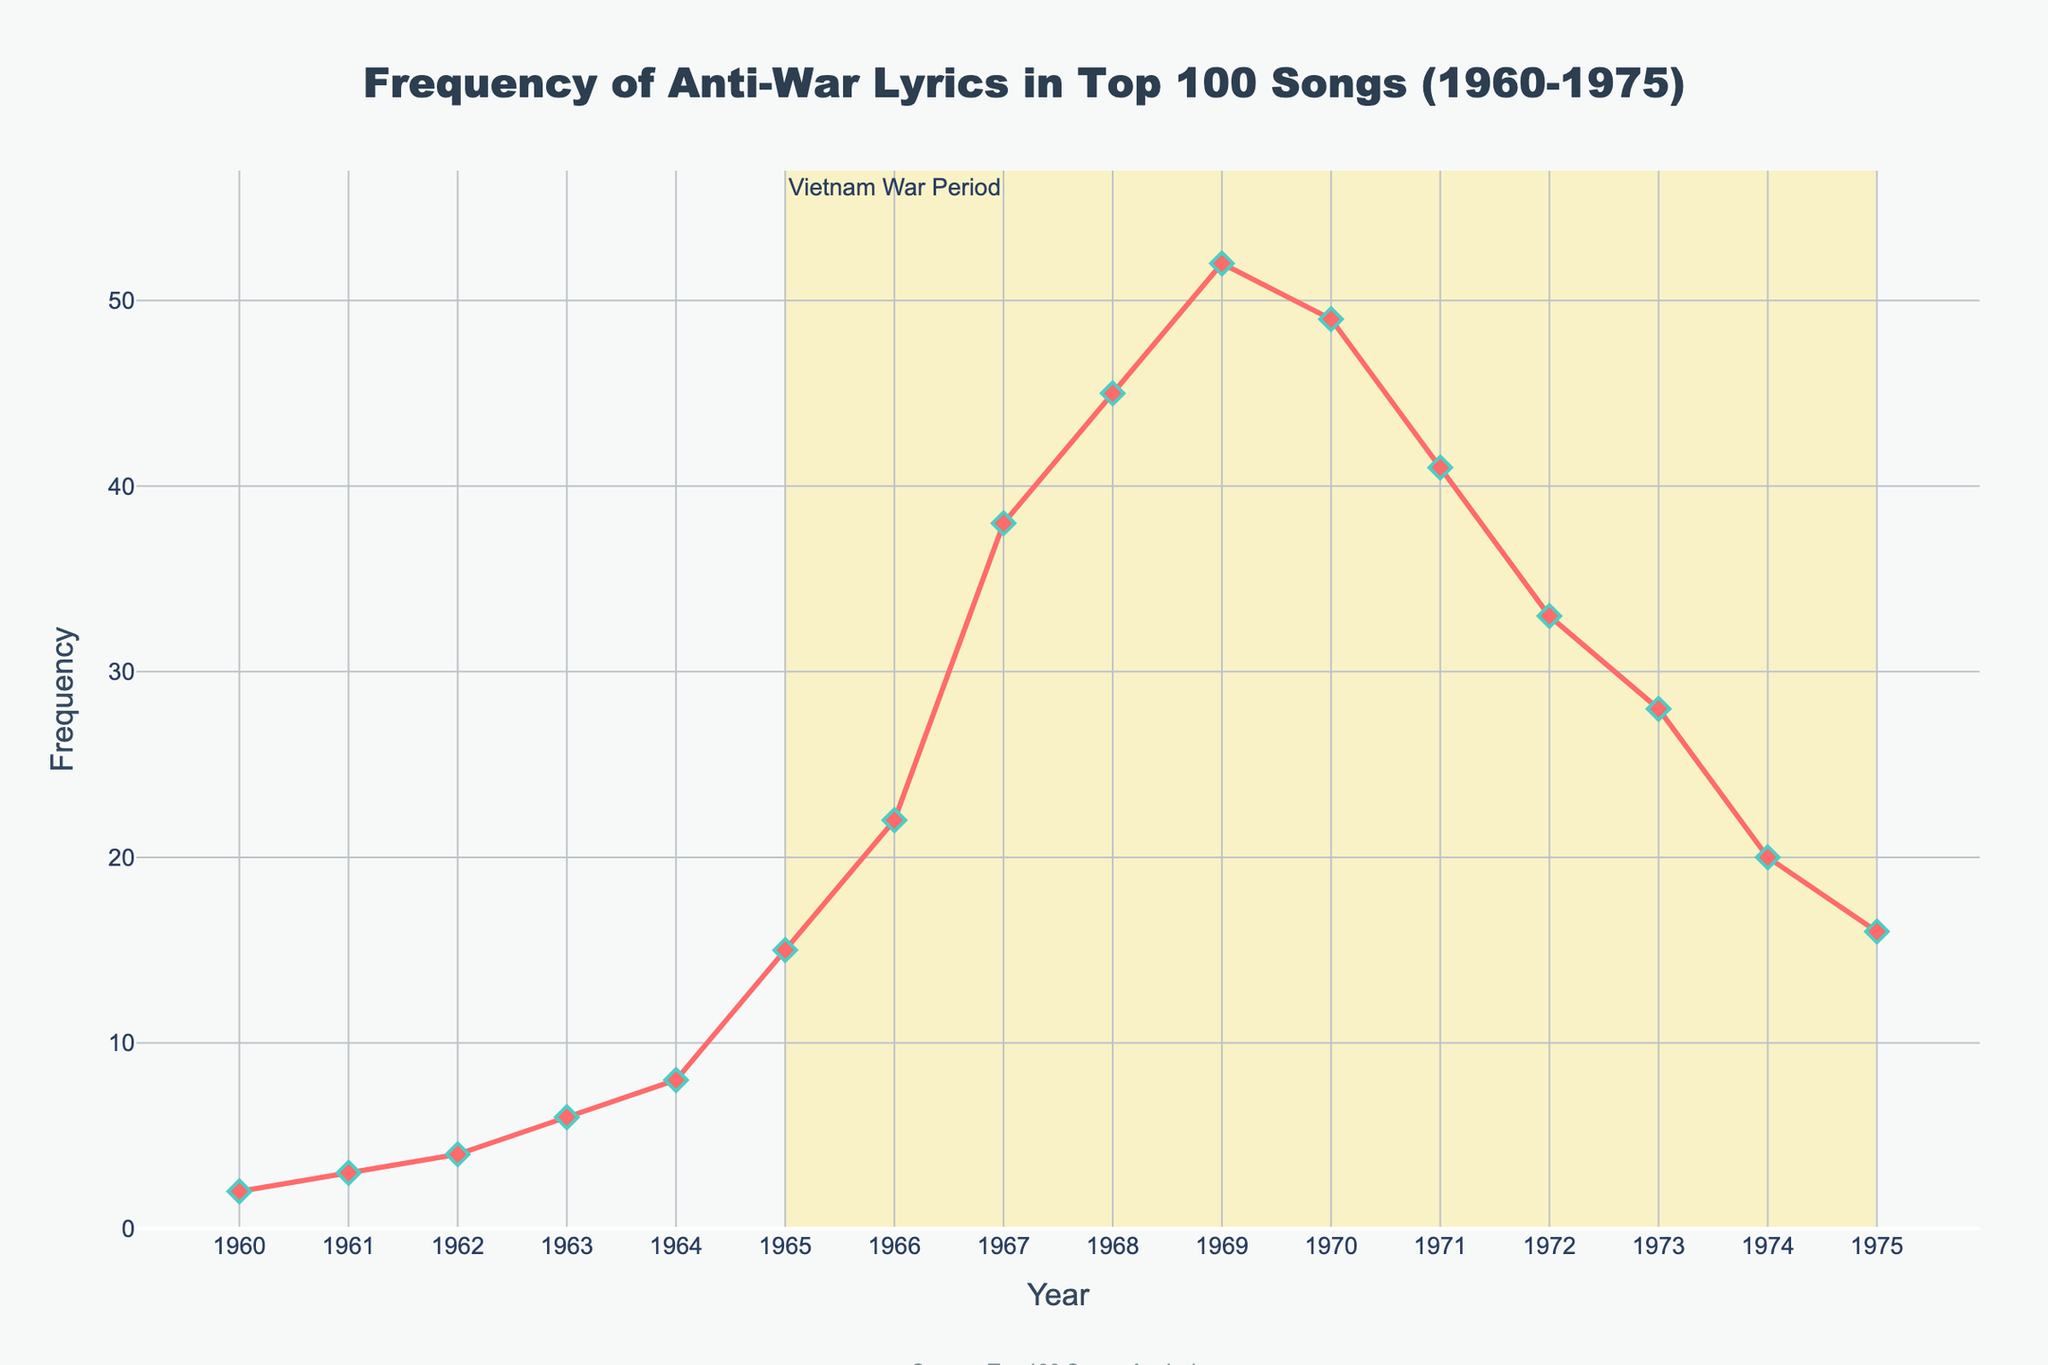What's the peak frequency of anti-war lyrics in the top 100 songs from 1960-1975? By examining the line chart, identify the highest point reached by the line representing the frequency of anti-war lyrics. The peak point occurs in 1969 where the frequency is 52.
Answer: 52 How did the frequency change from 1968 to 1970? Check the frequency values for the years 1968 and 1970. In 1968, the frequency is 45, and in 1970, it is 49. So, the frequency increased by 4.
Answer: Increased by 4 Which year saw the fastest increase in anti-war lyrics frequency? Compare the frequency differences year by year. The most significant increase happened between 1966 and 1967, where the frequency jumped from 22 to 38, a difference of 16.
Answer: 1967 What is the average frequency of anti-war lyrics over the period 1960-1975? Sum the frequencies from 1960 to 1975 and divide by the number of years (16). Total sum = 2+3+4+6+8+15+22+38+45+52+49+41+33+28+20+16 = 382. Hence, the average is 382/16 = 23.875.
Answer: 23.875 Compare the frequency of anti-war lyrics in 1965 and 1975. Look at the values for the years 1965 and 1975. In 1965, the frequency is 15, while in 1975, it is 16. The frequency is almost the same with a slight increase by 1 from 1965 to 1975.
Answer: 1975 is higher by 1 During which years did the frequency remain relatively stable, showing less year-to-year fluctuation? Identify periods where changes between consecutive years are minimal. From 1970 to 1973, the changes are: 49 in 1970, 41 in 1971, 33 in 1972, and 28 in 1973, showing less dramatic fluctuations compared to previous periods.
Answer: 1970-1973 What is the frequency of anti-war lyrics during the start and end of the Vietnam War period as marked in the plot? Examine the plot for values at the beginning and end of the shaded area (1965-1975). In 1965, the frequency is 15, and in 1975, it is 16.
Answer: Start: 15, End: 16 